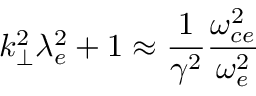<formula> <loc_0><loc_0><loc_500><loc_500>k _ { \perp } ^ { 2 } \lambda _ { e } ^ { 2 } + 1 \approx \frac { 1 } { \gamma ^ { 2 } } \frac { \omega _ { c e } ^ { 2 } } { \omega _ { e } ^ { 2 } }</formula> 